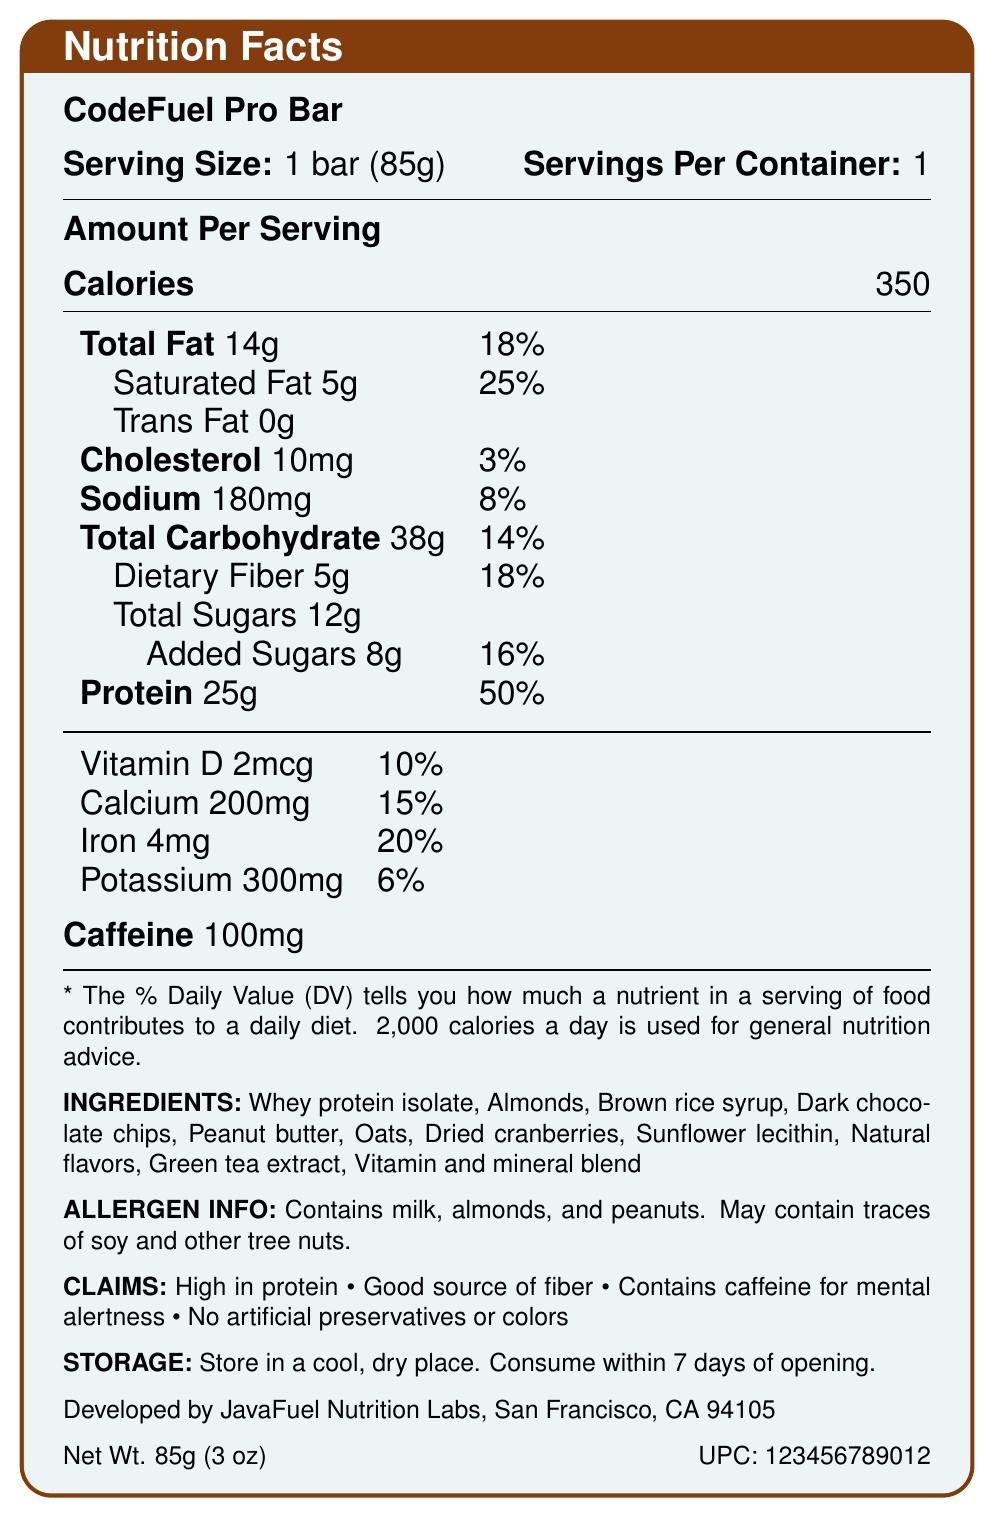what is the serving size of CodeFuel Pro Bar? The serving size is explicitly listed on the Nutrition Facts Label as "1 bar (85g)."
Answer: 1 bar (85g) how much protein does each serving of CodeFuel Pro Bar provide? The amount of protein per serving is given as 25 grams.
Answer: 25g how much caffeine does the CodeFuel Pro Bar contain? The caffeine content is specified in the document as 100mg.
Answer: 100mg how many total grams of carbohydrates are there in the CodeFuel Pro Bar? The total carbohydrate content per serving is listed as 38 grams.
Answer: 38g what percentage of the daily value is the saturated fat content? The saturated fat percentage of the daily value is given as 25%.
Answer: 25% which vitamins and minerals are listed with their daily values? A. Vitamin C, Calcium, Iron, Potassium B. Vitamin D, Calcium, Iron, Potassium C. Vitamin A, Calcium, Iron, Magnesium The document mentions Vitamin D (10%), Calcium (15%), Iron (20%), and Potassium (6%).
Answer: B which of the following is a claim made about the CodeFuel Pro Bar? A. Low in sugar B. High in protein C. Gluten-free The claim "High in protein" is stated in the document, while the other options are not mentioned as claims.
Answer: B is the CodeFuel Pro Bar suitable for someone with a peanut allergy? The allergen information includes peanuts, indicating that it contains peanuts and thus is not suitable for someone with a peanut allergy.
Answer: No describe the overall nutritional profile and claims of the CodeFuel Pro Bar. The detailed description includes the main nutritional facts, ingredients, claims, and allergen information presented in the document, providing a comprehensive overview of the product.
Answer: The CodeFuel Pro Bar is a high-protein, high-calorie energy bar designed for long coding sessions. It contains 350 calories per serving, 25 grams of protein, significant amounts of vitamins and minerals, and 100mg of caffeine. The bar is also high in dietary fiber and includes ingredients like whey protein isolate, almonds, and peanut butter. It claims to be high in protein, a good source of fiber, and contains caffeine for mental alertness while having no artificial preservatives or colors. Allergen information indicates it contains milk, almonds, and peanuts. what company manufactures the CodeFuel Pro Bar? The manufacturer is listed as JavaFuel Nutrition Labs, San Francisco, CA 94105.
Answer: JavaFuel Nutrition Labs, San Francisco, CA 94105 how many grams of added sugars are in the CodeFuel Pro Bar? Added sugars are explicitly listed as 8 grams on the label.
Answer: 8g what is the UPC code of the CodeFuel Pro Bar? The UPC code is provided in the document as 123456789012.
Answer: 123456789012 what flavor does the CodeFuel Pro Bar have? The document does not include any information regarding the flavor of the bar.
Answer: Cannot be determined what are some of the main ingredients in the CodeFuel Pro Bar? Several main ingredients such as whey protein isolate, almonds, brown rice syrup, and dark chocolate chips are listed among others in the document.
Answer: Whey protein isolate, Almonds, Brown rice syrup, Dark chocolate chips 